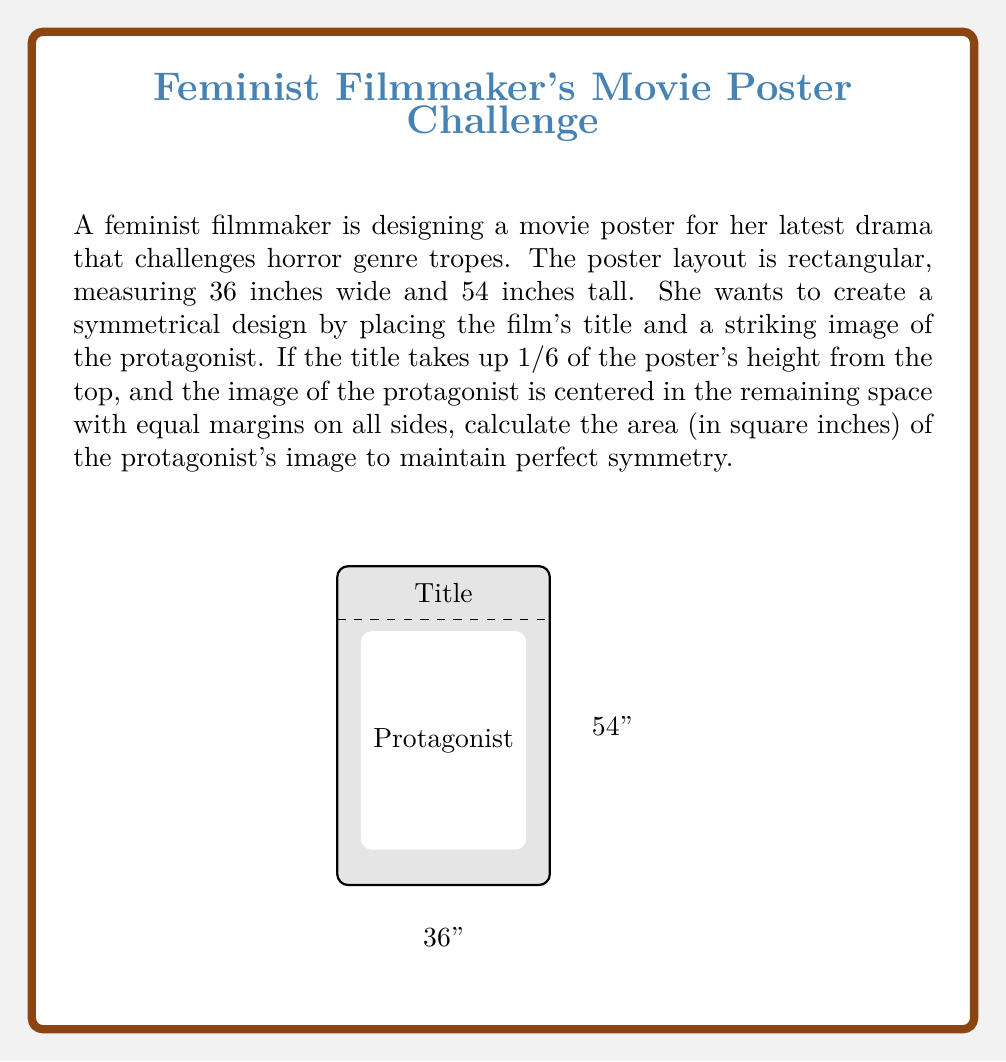Could you help me with this problem? Let's approach this step-by-step:

1) First, calculate the height of the title section:
   $\frac{1}{6}$ of 54 inches = $54 \times \frac{1}{6} = 9$ inches

2) The remaining height for the protagonist's image and margins:
   $54 - 9 = 45$ inches

3) For perfect symmetry, the margins on all sides of the image should be equal. Let's call this margin $x$.

4) The width of the image will be:
   $36 - 2x$ inches

5) The height of the image will be:
   $45 - 2x$ inches

6) For the image to be symmetrical within the remaining space, its aspect ratio should match that of the poster:

   $$\frac{36}{54} = \frac{36-2x}{45-2x}$$

7) Cross multiply:
   $36(45-2x) = 54(36-2x)$
   $1620 - 72x = 1944 - 108x$
   $36x = 324$
   $x = 9$ inches

8) Now we can calculate the dimensions of the image:
   Width: $36 - 2(9) = 18$ inches
   Height: $45 - 2(9) = 27$ inches

9) The area of the protagonist's image:
   $18 \times 27 = 486$ square inches
Answer: 486 sq in 